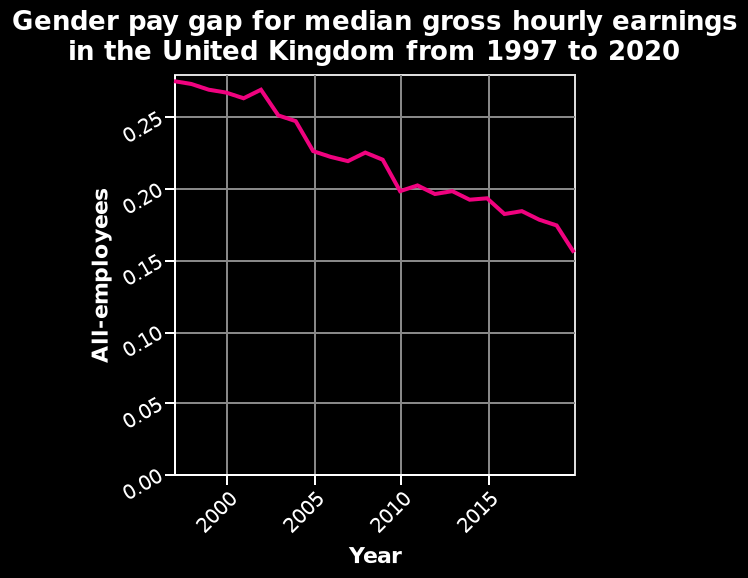<image>
What does the graph depict? The graph shows the trend of the gender pay gap from 1997 to 2020. 